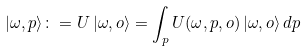Convert formula to latex. <formula><loc_0><loc_0><loc_500><loc_500>| \omega , p \rangle \colon = U \, | \omega , o \rangle = \int _ { p } U ( \omega , p , o ) \, | \omega , o \rangle \, d p \,</formula> 